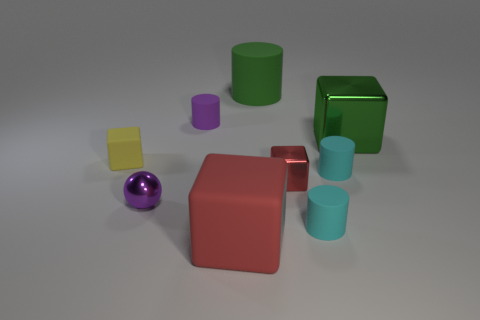What shape is the red object that is the same size as the green rubber cylinder?
Your answer should be compact. Cube. How many things are either big objects left of the big green cylinder or yellow shiny cubes?
Your answer should be very brief. 1. Do the tiny sphere and the large cylinder have the same color?
Give a very brief answer. No. How big is the metallic block left of the green block?
Offer a very short reply. Small. Is there a cylinder of the same size as the green rubber object?
Your response must be concise. No. Do the cylinder that is to the left of the green rubber thing and the small purple metallic ball have the same size?
Keep it short and to the point. Yes. The metal ball is what size?
Your answer should be compact. Small. What is the color of the small cube on the left side of the small cylinder to the left of the large green thing left of the large green shiny object?
Your answer should be very brief. Yellow. There is a large cube that is behind the yellow rubber thing; does it have the same color as the tiny rubber cube?
Keep it short and to the point. No. How many large objects are behind the yellow matte object and on the left side of the small metal cube?
Ensure brevity in your answer.  1. 